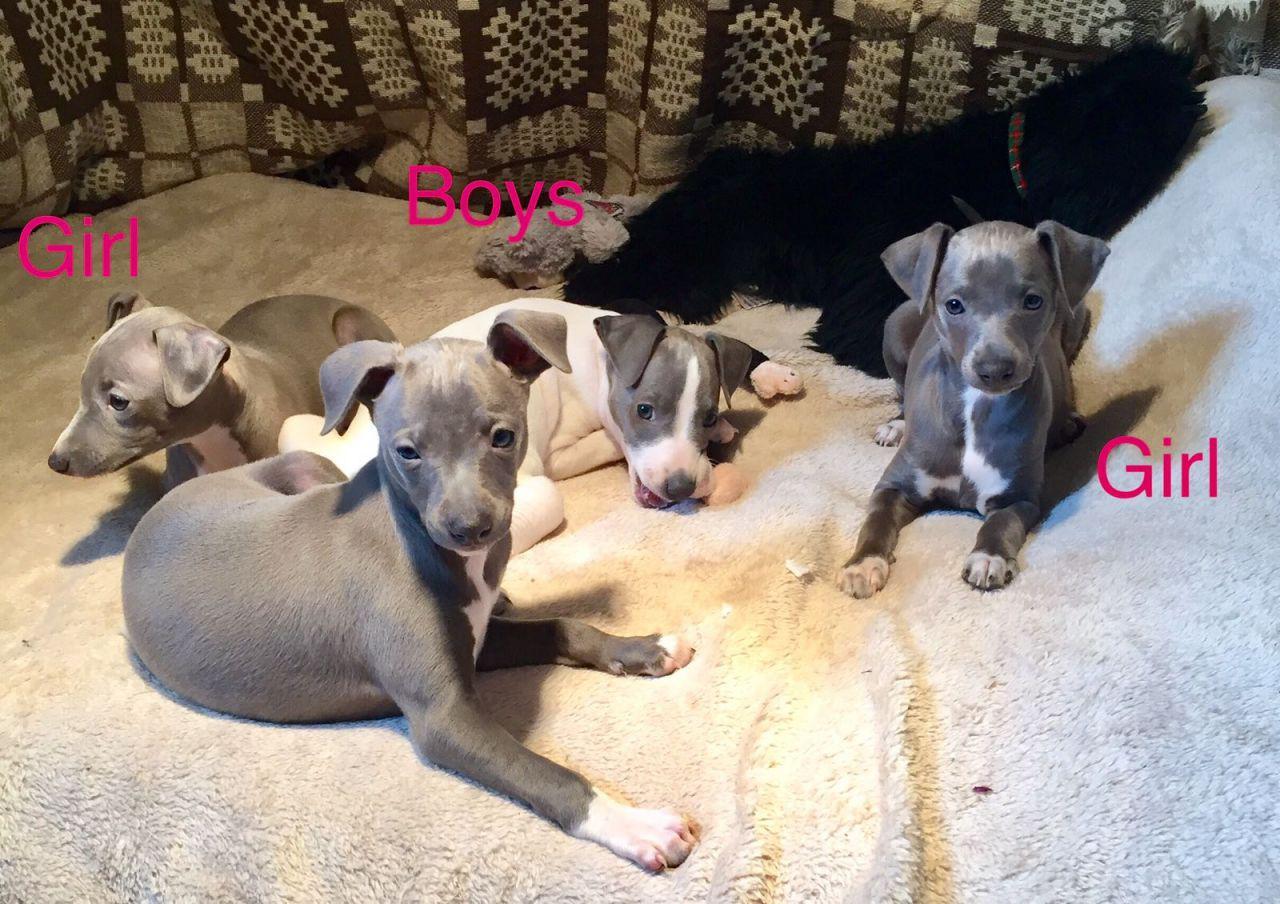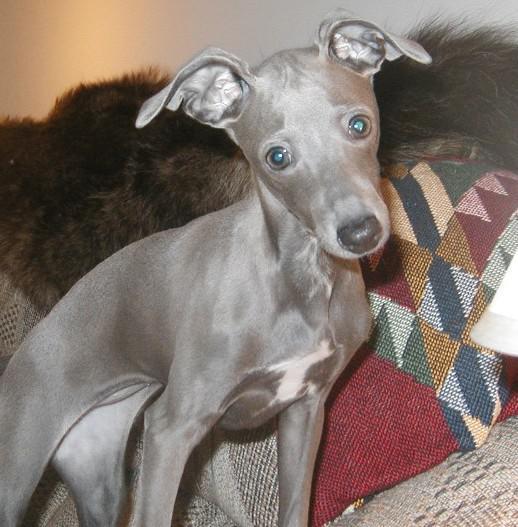The first image is the image on the left, the second image is the image on the right. Analyze the images presented: Is the assertion "None of the dogs are wearing collars." valid? Answer yes or no. Yes. The first image is the image on the left, the second image is the image on the right. Analyze the images presented: Is the assertion "There are at least four gray and white puppies." valid? Answer yes or no. Yes. 